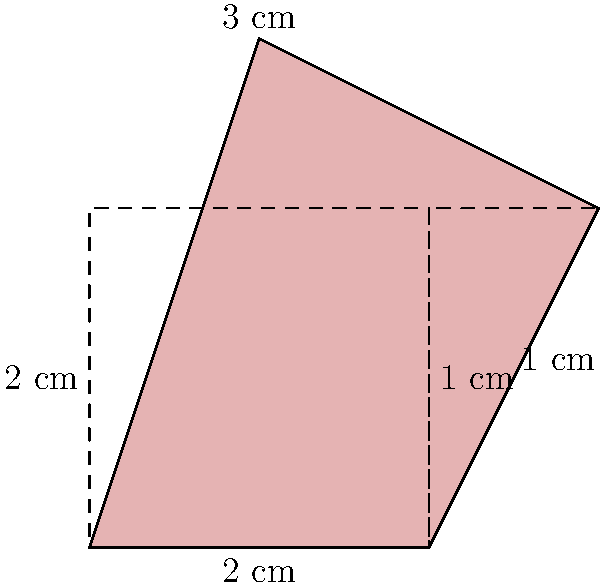As an aspiring intensive care specialist, you're assessing a patient with an irregularly shaped wound. To estimate the area for proper treatment, you decide to approximate the wound's shape using basic geometric figures. The wound can be divided into a rectangle and a right-angled triangle, as shown in the diagram. If the rectangle measures 2 cm by 2 cm, and the triangle has a base of 1 cm and a height of 2 cm, what is the total area of the wound in square centimeters? To calculate the total area of the wound, we need to sum the areas of the rectangle and the triangle:

1. Area of the rectangle:
   $A_{rectangle} = length * width = 2 \text{ cm} * 2 \text{ cm} = 4 \text{ cm}^2$

2. Area of the right-angled triangle:
   $A_{triangle} = \frac{1}{2} * base * height = \frac{1}{2} * 1 \text{ cm} * 2 \text{ cm} = 1 \text{ cm}^2$

3. Total area of the wound:
   $A_{total} = A_{rectangle} + A_{triangle} = 4 \text{ cm}^2 + 1 \text{ cm}^2 = 5 \text{ cm}^2$

Therefore, the total area of the wound is 5 square centimeters.
Answer: $5 \text{ cm}^2$ 